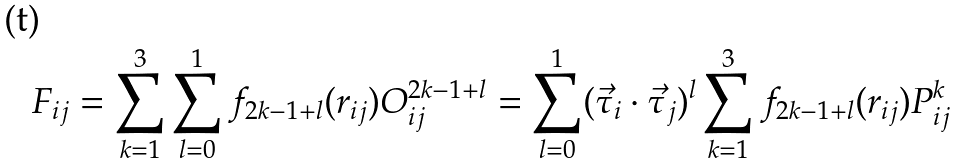Convert formula to latex. <formula><loc_0><loc_0><loc_500><loc_500>F _ { i j } = \sum _ { k = 1 } ^ { 3 } \sum _ { l = 0 } ^ { 1 } f _ { 2 k - 1 + l } ( r _ { i j } ) O ^ { 2 k - 1 + l } _ { i j } = \sum _ { l = 0 } ^ { 1 } ( \vec { \tau } _ { i } \cdot \vec { \tau } _ { j } ) ^ { l } \sum _ { k = 1 } ^ { 3 } f _ { 2 k - 1 + l } ( r _ { i j } ) P ^ { k } _ { i j }</formula> 